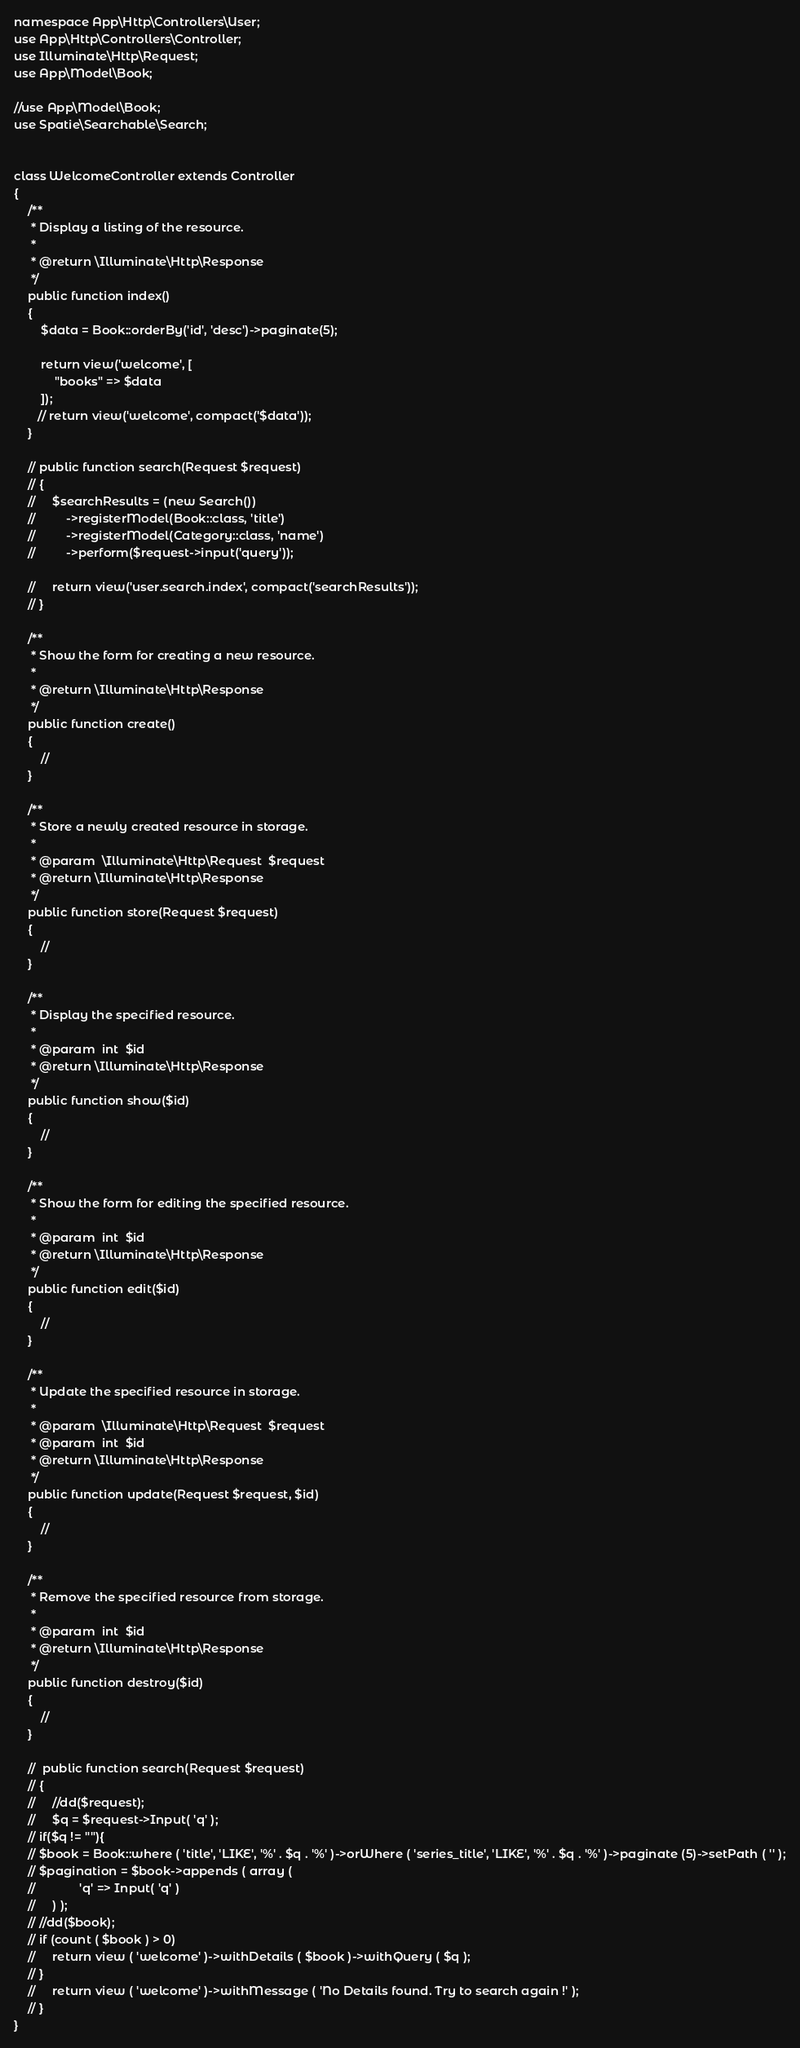Convert code to text. <code><loc_0><loc_0><loc_500><loc_500><_PHP_>namespace App\Http\Controllers\User;
use App\Http\Controllers\Controller;
use Illuminate\Http\Request;
use App\Model\Book;

//use App\Model\Book;
use Spatie\Searchable\Search;


class WelcomeController extends Controller
{
    /**
     * Display a listing of the resource.
     *
     * @return \Illuminate\Http\Response
     */
    public function index()
    {
        $data = Book::orderBy('id', 'desc')->paginate(5);

        return view('welcome', [
            "books" => $data
        ]);
       // return view('welcome', compact('$data'));
    }

    // public function search(Request $request)
    // {
    //     $searchResults = (new Search())
    //         ->registerModel(Book::class, 'title')
    //         ->registerModel(Category::class, 'name')
    //         ->perform($request->input('query'));

    //     return view('user.search.index', compact('searchResults'));
    // }

    /**
     * Show the form for creating a new resource.
     *
     * @return \Illuminate\Http\Response
     */
    public function create()
    {
        //
    }

    /**
     * Store a newly created resource in storage.
     *
     * @param  \Illuminate\Http\Request  $request
     * @return \Illuminate\Http\Response
     */
    public function store(Request $request)
    {
        //
    }

    /**
     * Display the specified resource.
     *
     * @param  int  $id
     * @return \Illuminate\Http\Response
     */
    public function show($id)
    {
        //
    }

    /**
     * Show the form for editing the specified resource.
     *
     * @param  int  $id
     * @return \Illuminate\Http\Response
     */
    public function edit($id)
    {
        //
    }

    /**
     * Update the specified resource in storage.
     *
     * @param  \Illuminate\Http\Request  $request
     * @param  int  $id
     * @return \Illuminate\Http\Response
     */
    public function update(Request $request, $id)
    {
        //
    }

    /**
     * Remove the specified resource from storage.
     *
     * @param  int  $id
     * @return \Illuminate\Http\Response
     */
    public function destroy($id)
    {
        //
    }

    //  public function search(Request $request)
    // {
    //     //dd($request);
    //     $q = $request->Input( 'q' );
    // if($q != ""){
    // $book = Book::where ( 'title', 'LIKE', '%' . $q . '%' )->orWhere ( 'series_title', 'LIKE', '%' . $q . '%' )->paginate (5)->setPath ( '' );
    // $pagination = $book->appends ( array (
    //             'q' => Input( 'q' ) 
    //     ) );
    // //dd($book);
    // if (count ( $book ) > 0)
    //     return view ( 'welcome' )->withDetails ( $book )->withQuery ( $q );
    // }
    //     return view ( 'welcome' )->withMessage ( 'No Details found. Try to search again !' );
    // }
}
</code> 